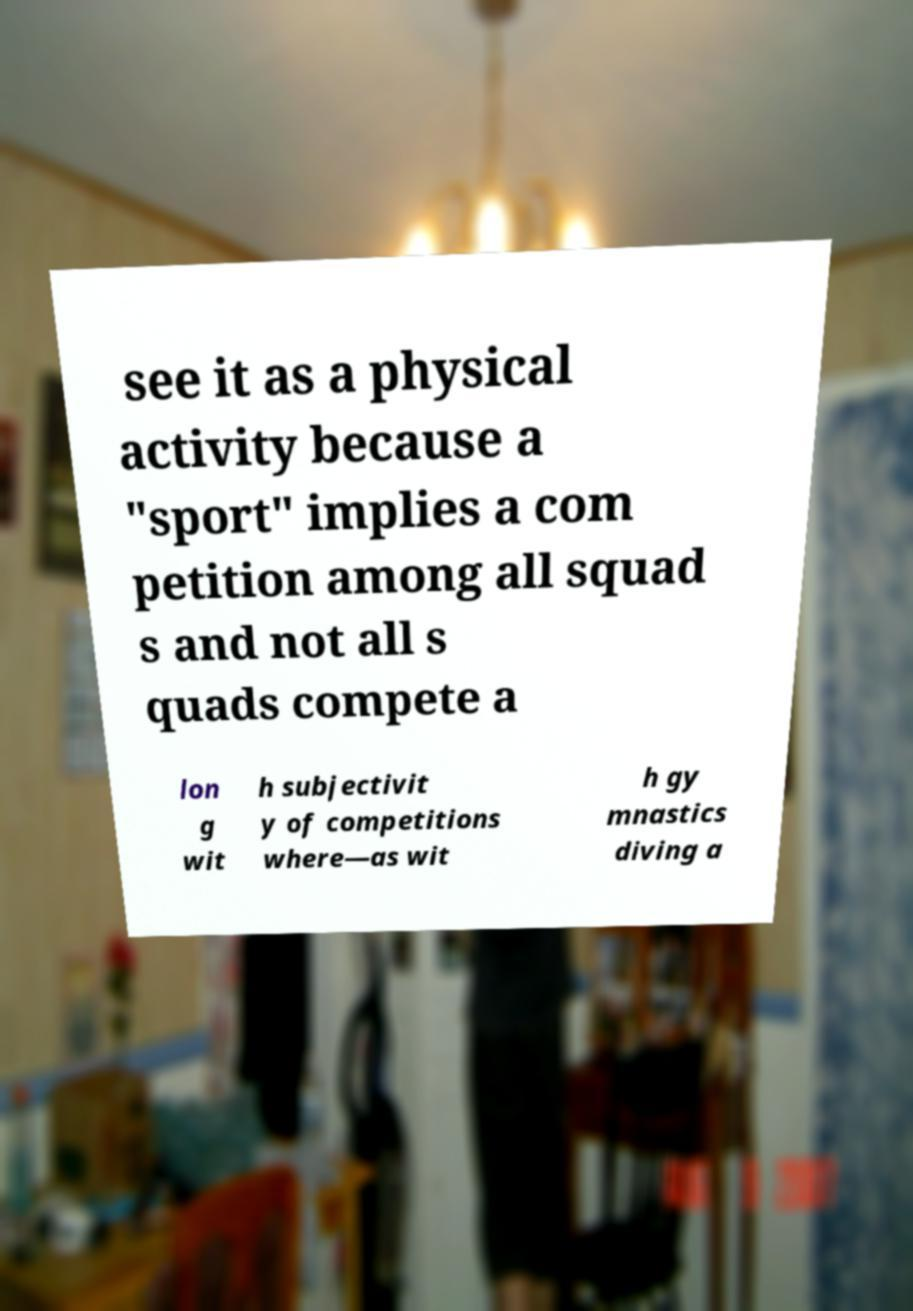There's text embedded in this image that I need extracted. Can you transcribe it verbatim? see it as a physical activity because a "sport" implies a com petition among all squad s and not all s quads compete a lon g wit h subjectivit y of competitions where—as wit h gy mnastics diving a 